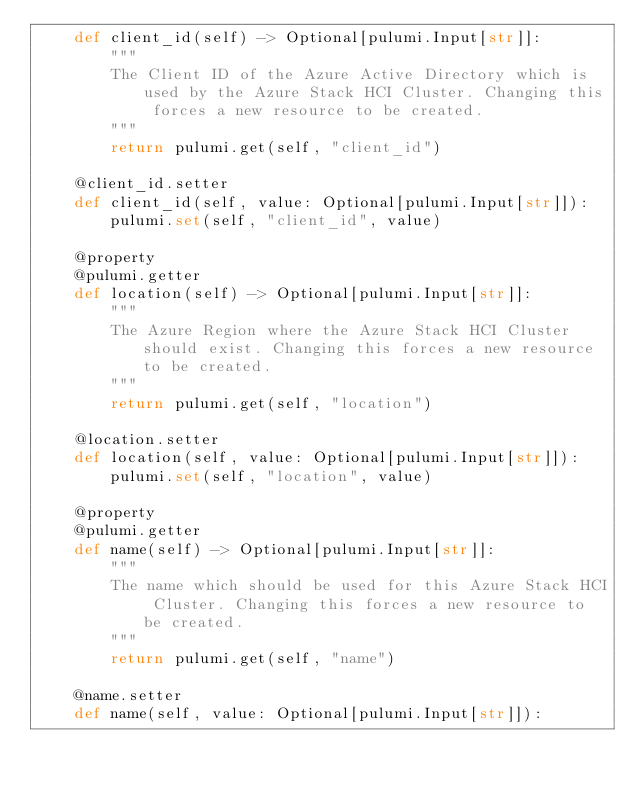<code> <loc_0><loc_0><loc_500><loc_500><_Python_>    def client_id(self) -> Optional[pulumi.Input[str]]:
        """
        The Client ID of the Azure Active Directory which is used by the Azure Stack HCI Cluster. Changing this forces a new resource to be created.
        """
        return pulumi.get(self, "client_id")

    @client_id.setter
    def client_id(self, value: Optional[pulumi.Input[str]]):
        pulumi.set(self, "client_id", value)

    @property
    @pulumi.getter
    def location(self) -> Optional[pulumi.Input[str]]:
        """
        The Azure Region where the Azure Stack HCI Cluster should exist. Changing this forces a new resource to be created.
        """
        return pulumi.get(self, "location")

    @location.setter
    def location(self, value: Optional[pulumi.Input[str]]):
        pulumi.set(self, "location", value)

    @property
    @pulumi.getter
    def name(self) -> Optional[pulumi.Input[str]]:
        """
        The name which should be used for this Azure Stack HCI Cluster. Changing this forces a new resource to be created.
        """
        return pulumi.get(self, "name")

    @name.setter
    def name(self, value: Optional[pulumi.Input[str]]):</code> 